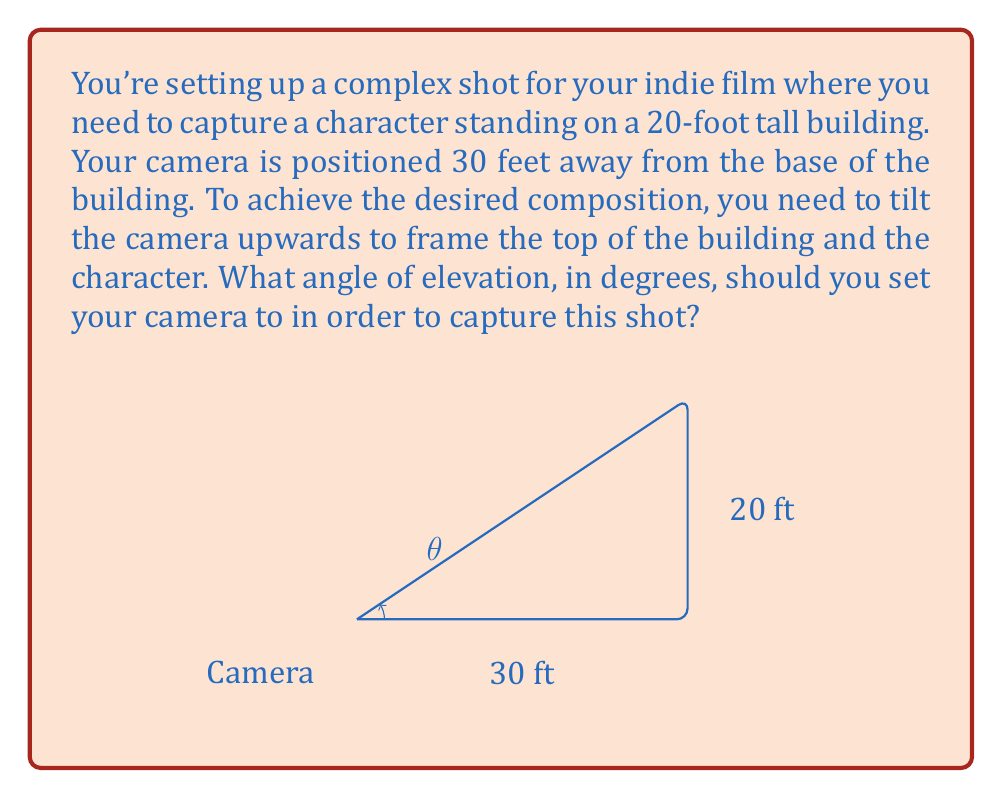Could you help me with this problem? To solve this problem, we need to use trigonometry, specifically the tangent function. Let's break it down step-by-step:

1) First, let's visualize the scenario. We have a right triangle where:
   - The base (adjacent side) is 30 feet (distance from camera to building)
   - The height (opposite side) is 20 feet (height of the building)
   - The angle we're looking for is the angle of elevation of the camera

2) In a right triangle, tangent of an angle is the ratio of the opposite side to the adjacent side:

   $$\tan(\theta) = \frac{\text{opposite}}{\text{adjacent}}$$

3) Plugging in our values:

   $$\tan(\theta) = \frac{20}{30}$$

4) To find the angle $\theta$, we need to use the inverse tangent (arctan or $\tan^{-1}$):

   $$\theta = \tan^{-1}(\frac{20}{30})$$

5) Simplify the fraction:

   $$\theta = \tan^{-1}(\frac{2}{3})$$

6) Use a calculator or trigonometric tables to evaluate:

   $$\theta \approx 33.69^\circ$$

7) Round to two decimal places:

   $$\theta \approx 33.69^\circ$$

This angle will ensure that your camera captures the top of the 20-foot building when positioned 30 feet away from its base.
Answer: $33.69^\circ$ 